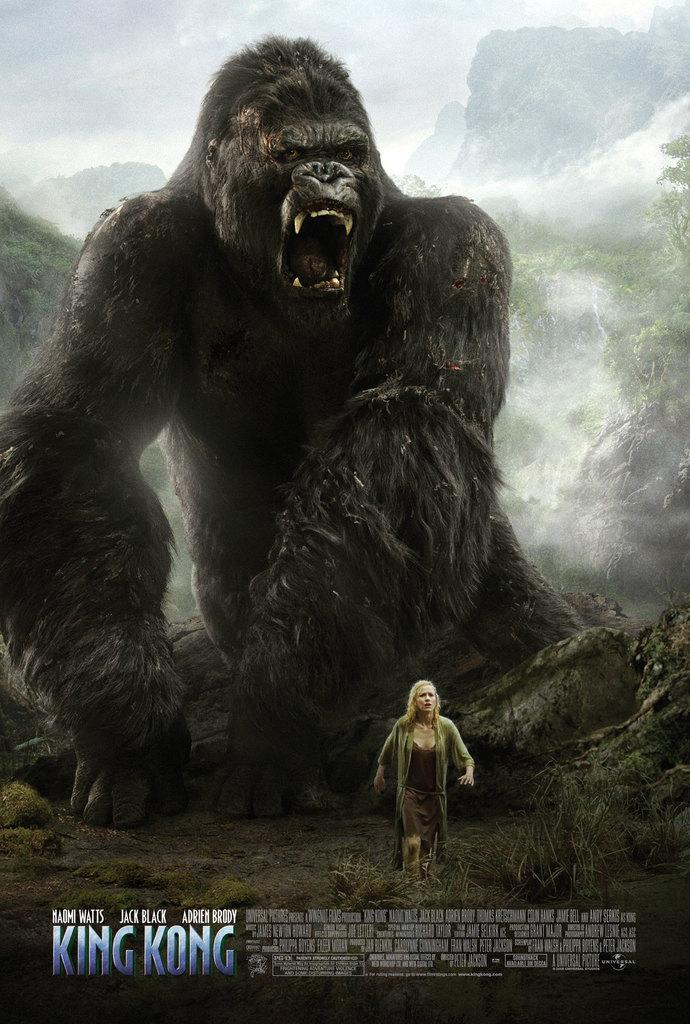What type of image is being described? The image is a movie poster. What is the main subject of the movie poster? There is a gorilla in the poster. Are there any other characters or elements in the poster? Yes, there is a woman in the poster. What type of cactus can be seen in the movie poster? There is no cactus present in the movie poster; it features a gorilla and a woman. 